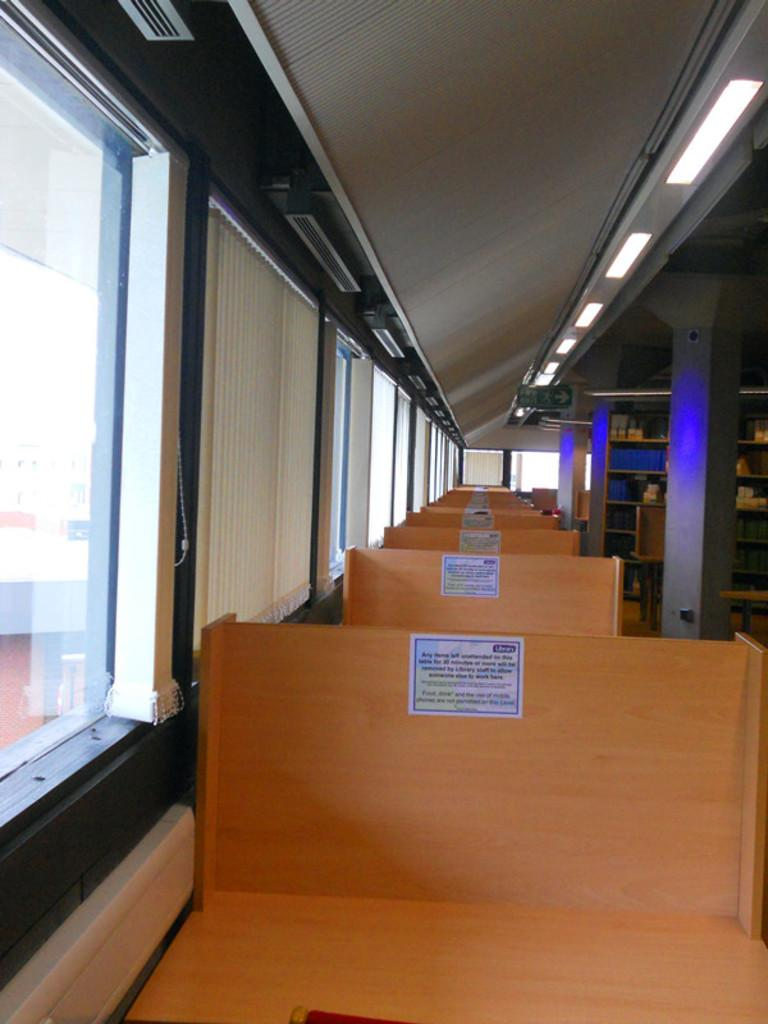What type of furniture is present in the image? There are benches in the image. Where are the windows located in the image? The windows are on the left side of the image. What can be found on the racks in the image? The racks contain books. What is above the area in the image? There is a ceiling in the image. What provides illumination in the image? There are lights in the image. How many slaves are visible in the image? There are no slaves present in the image. What type of bears can be seen in the image? There are no bears present in the image. 